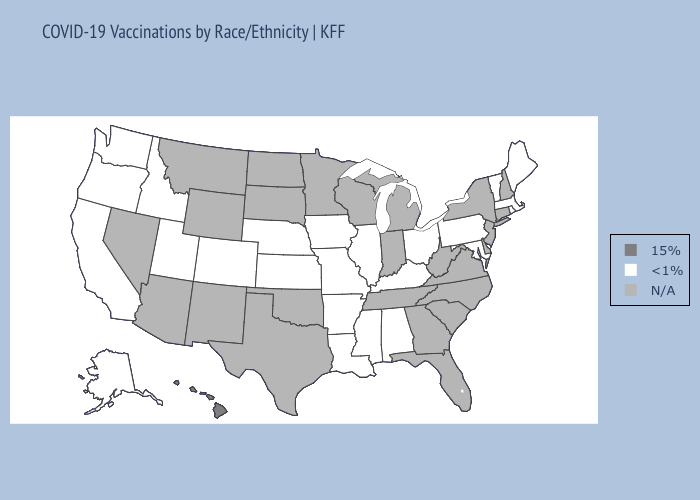What is the value of Tennessee?
Give a very brief answer. N/A. What is the highest value in the Northeast ?
Answer briefly. <1%. Which states have the highest value in the USA?
Quick response, please. Hawaii. What is the value of Nevada?
Write a very short answer. N/A. Name the states that have a value in the range <1%?
Write a very short answer. Alabama, Alaska, Arkansas, California, Colorado, Idaho, Illinois, Iowa, Kansas, Kentucky, Louisiana, Maine, Maryland, Massachusetts, Mississippi, Missouri, Nebraska, Ohio, Oregon, Pennsylvania, Rhode Island, Utah, Vermont, Washington. What is the value of Kansas?
Be succinct. <1%. What is the lowest value in the USA?
Short answer required. <1%. Among the states that border Arkansas , which have the highest value?
Quick response, please. Louisiana, Mississippi, Missouri. Name the states that have a value in the range 15%?
Give a very brief answer. Hawaii. 